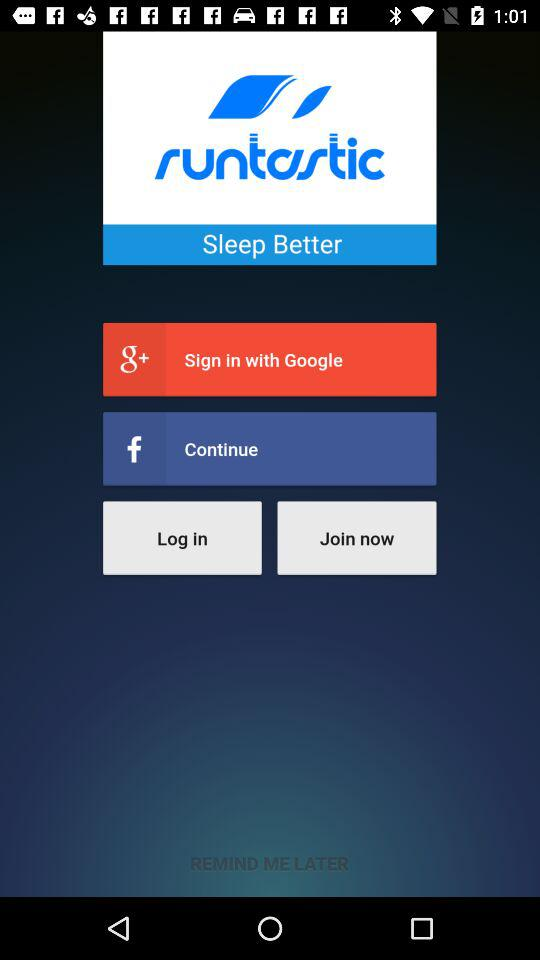How many sign in options are there?
Answer the question using a single word or phrase. 3 